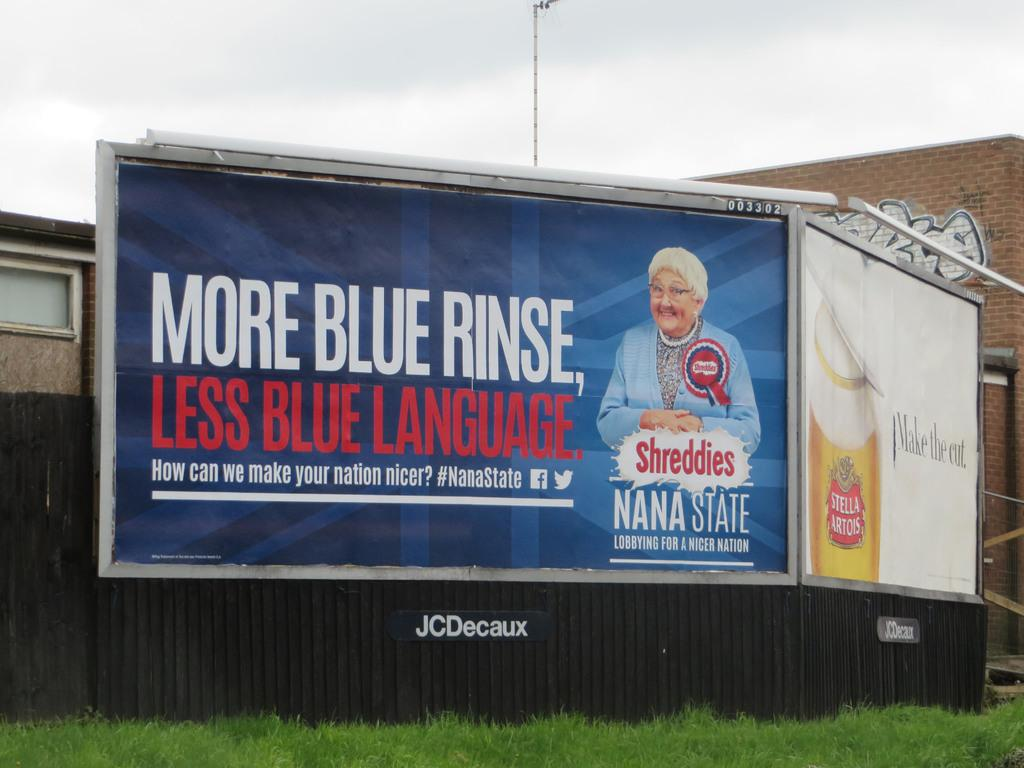Provide a one-sentence caption for the provided image. Bilboard advertising Nana State which is lobying for a nicer nation, "More blue rinse, less blue language. 